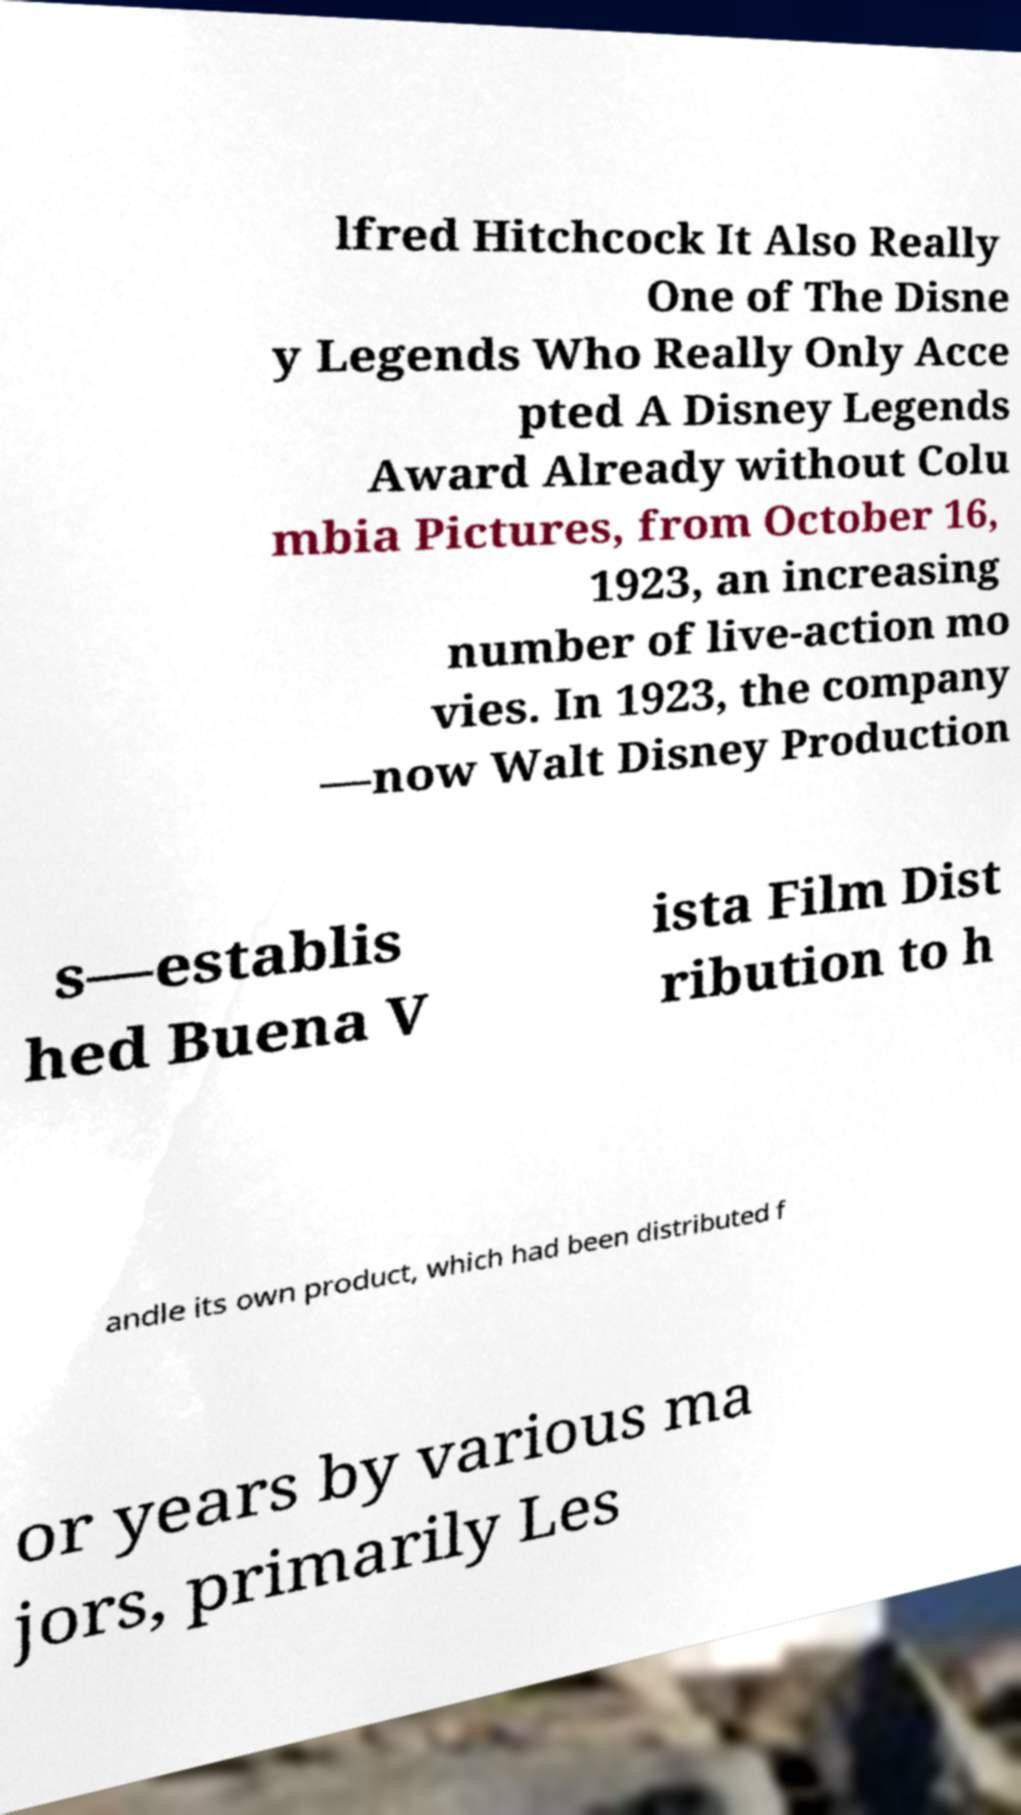Please read and relay the text visible in this image. What does it say? lfred Hitchcock It Also Really One of The Disne y Legends Who Really Only Acce pted A Disney Legends Award Already without Colu mbia Pictures, from October 16, 1923, an increasing number of live-action mo vies. In 1923, the company —now Walt Disney Production s—establis hed Buena V ista Film Dist ribution to h andle its own product, which had been distributed f or years by various ma jors, primarily Les 